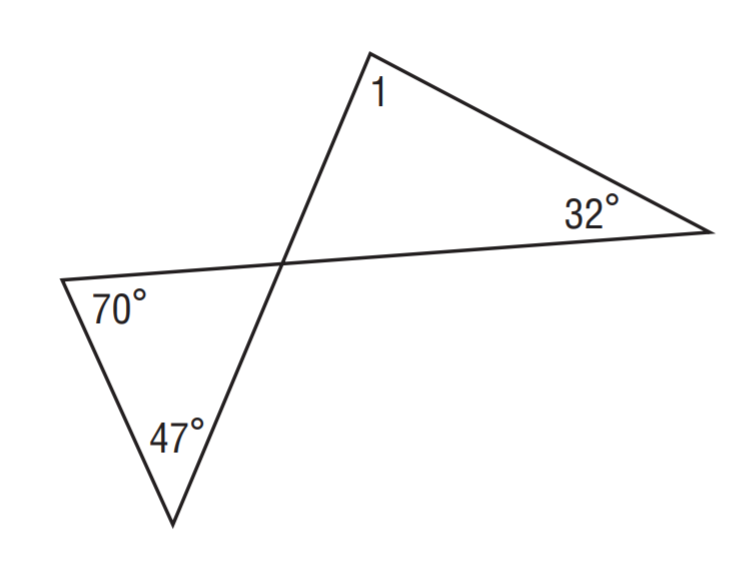Question: Find m \angle 1.
Choices:
A. 32
B. 47
C. 70
D. 85
Answer with the letter. Answer: D 